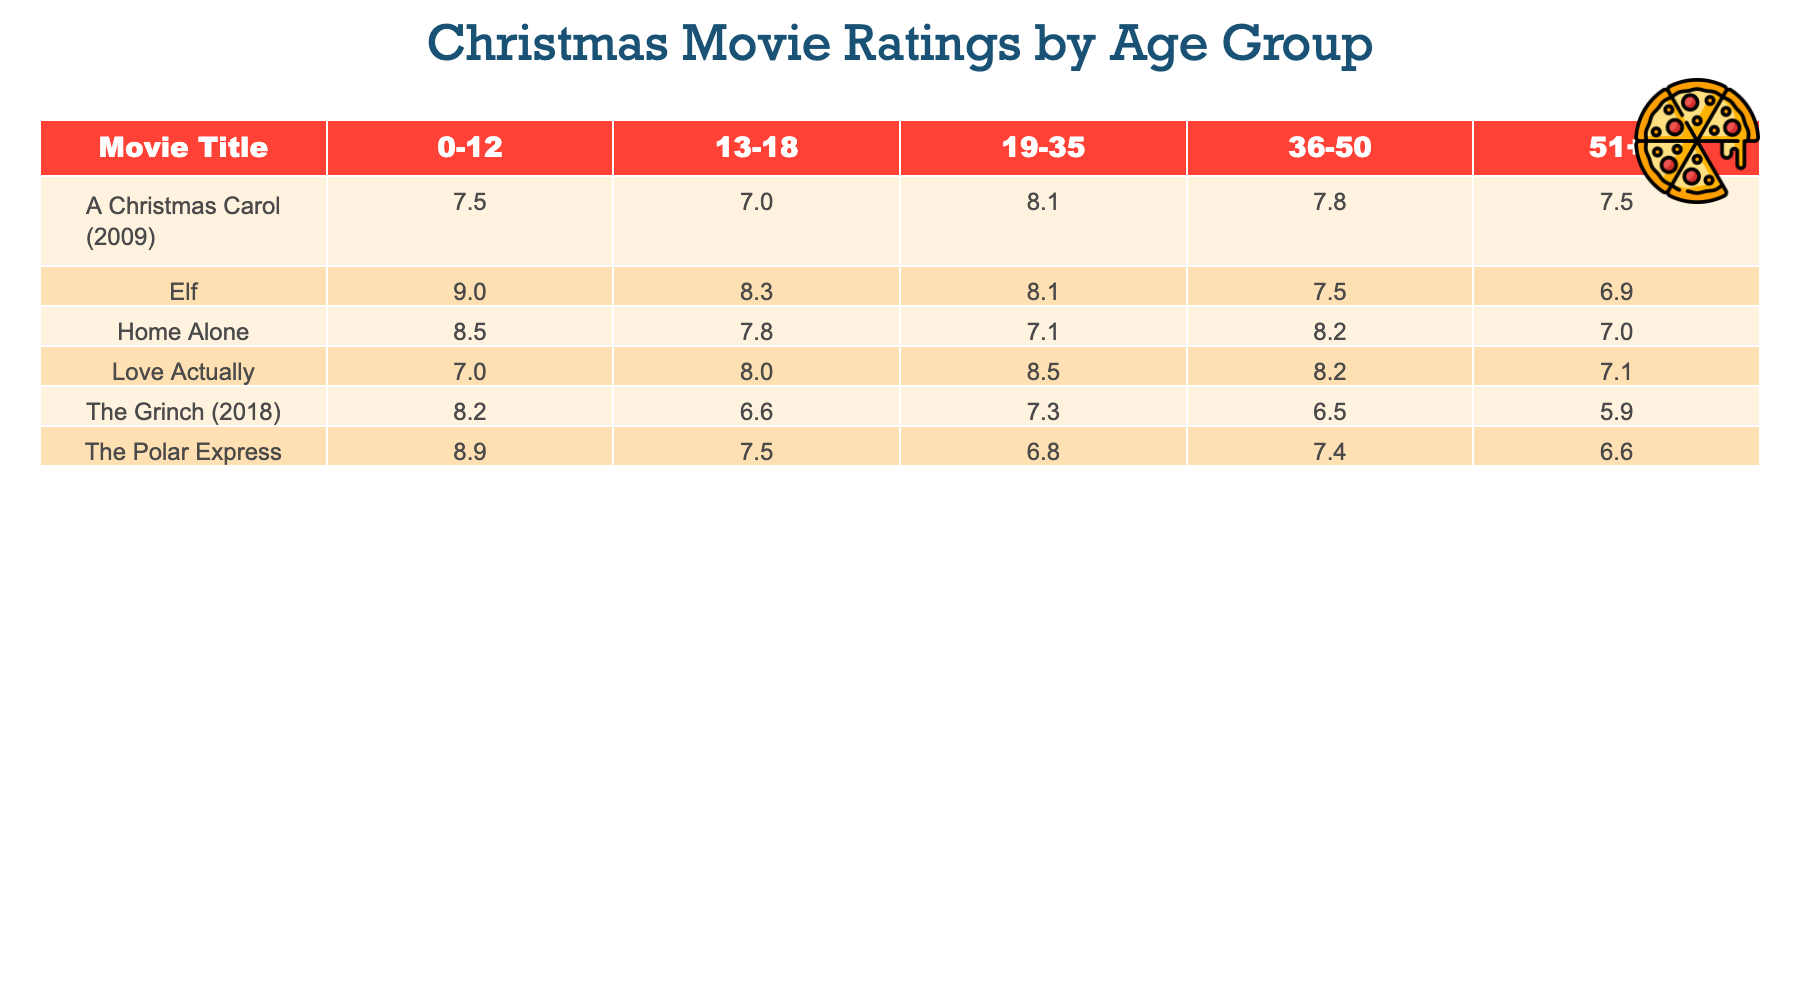What is the highest viewer rating for "Elf" in the age group 0-12? In the table, we can find the rating for "Elf" in the age group 0-12, which is 9.0. There are no other ratings for "Elf" in this age group, confirming it as the highest rating for the specified category.
Answer: 9.0 Which movie received the lowest rating from the age group 51+? Observing the table, we see that the lowest viewer rating under the age group 51+ is for "The Grinch (2018," with a score of 5.9. This is confirmed by comparing all the ratings for the age group 51+.
Answer: 5.9 What is the average viewer rating for "Home Alone"? To calculate the average, we sum the ratings for "Home Alone": (8.5 + 7.8 + 7.1 + 8.2 + 7.0) = 38.6. Then, we divide this total by the number of age groups (5) to find the average rating: 38.6 / 5 = 7.72.
Answer: 7.72 Did "A Christmas Carol (2009)" have a higher rating than "The Polar Express" in the age group 36-50? Comparing the ratings, "A Christmas Carol (2009)" has a rating of 7.8, while "The Polar Express" has a rating of 7.4 in the age group 36-50. Therefore, "A Christmas Carol (2009)" has a higher rating in this category.
Answer: Yes What is the difference in viewer ratings between "Love Actually" and "Elf" in the age group 19-35? In the table, "Love Actually" has a rating of 8.5 and "Elf" has a rating of 8.1 in the age group 19-35. Subtracting the two ratings, we find that the difference is 8.5 - 8.1 = 0.4.
Answer: 0.4 Which age group rated "The Grinch (2018)" higher, 0-12 or 19-35? For "The Grinch (2018)," the rating for the age group 0-12 is 8.2, while for 19-35, it is 7.3. Comparing the ratings shows that the 0-12 age group rated it higher.
Answer: 0-12 Is there an age group where "Home Alone" received the same or lower rating than "The Polar Express"? Looking at the 13-18 age group, "Home Alone" received a rating of 7.8, while "The Polar Express" had a lower rating of 7.5 for the same age group. This confirms that "Home Alone" received the same rating as or lower than "The Polar Express" in this age category.
Answer: Yes What movie has the best rating overall in the 0-12 age group? Upon reviewing the table, the best rating in the 0-12 age group is for "Elf," which received a score of 9.0. Thus, this movie has the highest viewer rating compared to all others in this age group.
Answer: Elf 